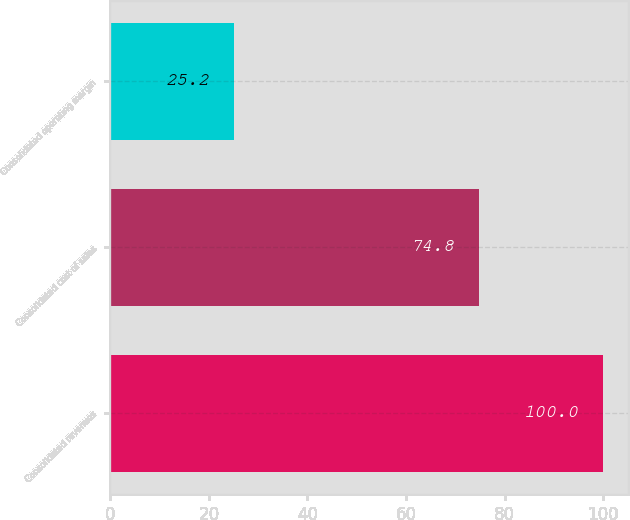Convert chart. <chart><loc_0><loc_0><loc_500><loc_500><bar_chart><fcel>Consolidated revenues<fcel>Consolidated cost of sales<fcel>Consolidated operating margin<nl><fcel>100<fcel>74.8<fcel>25.2<nl></chart> 